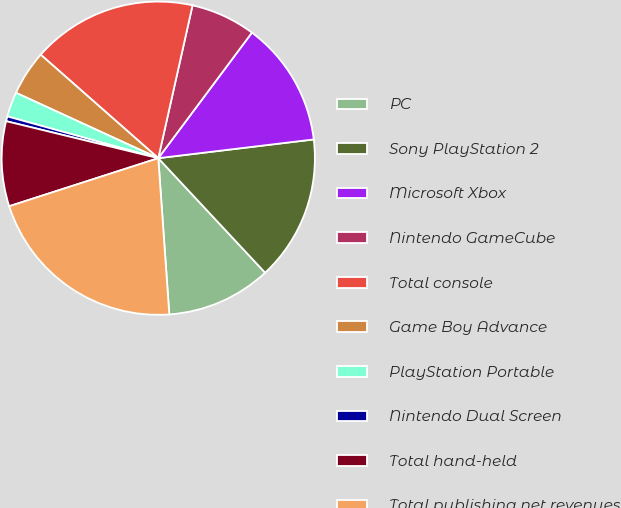<chart> <loc_0><loc_0><loc_500><loc_500><pie_chart><fcel>PC<fcel>Sony PlayStation 2<fcel>Microsoft Xbox<fcel>Nintendo GameCube<fcel>Total console<fcel>Game Boy Advance<fcel>PlayStation Portable<fcel>Nintendo Dual Screen<fcel>Total hand-held<fcel>Total publishing net revenues<nl><fcel>10.83%<fcel>14.96%<fcel>12.89%<fcel>6.69%<fcel>17.02%<fcel>4.63%<fcel>2.56%<fcel>0.5%<fcel>8.76%<fcel>21.16%<nl></chart> 